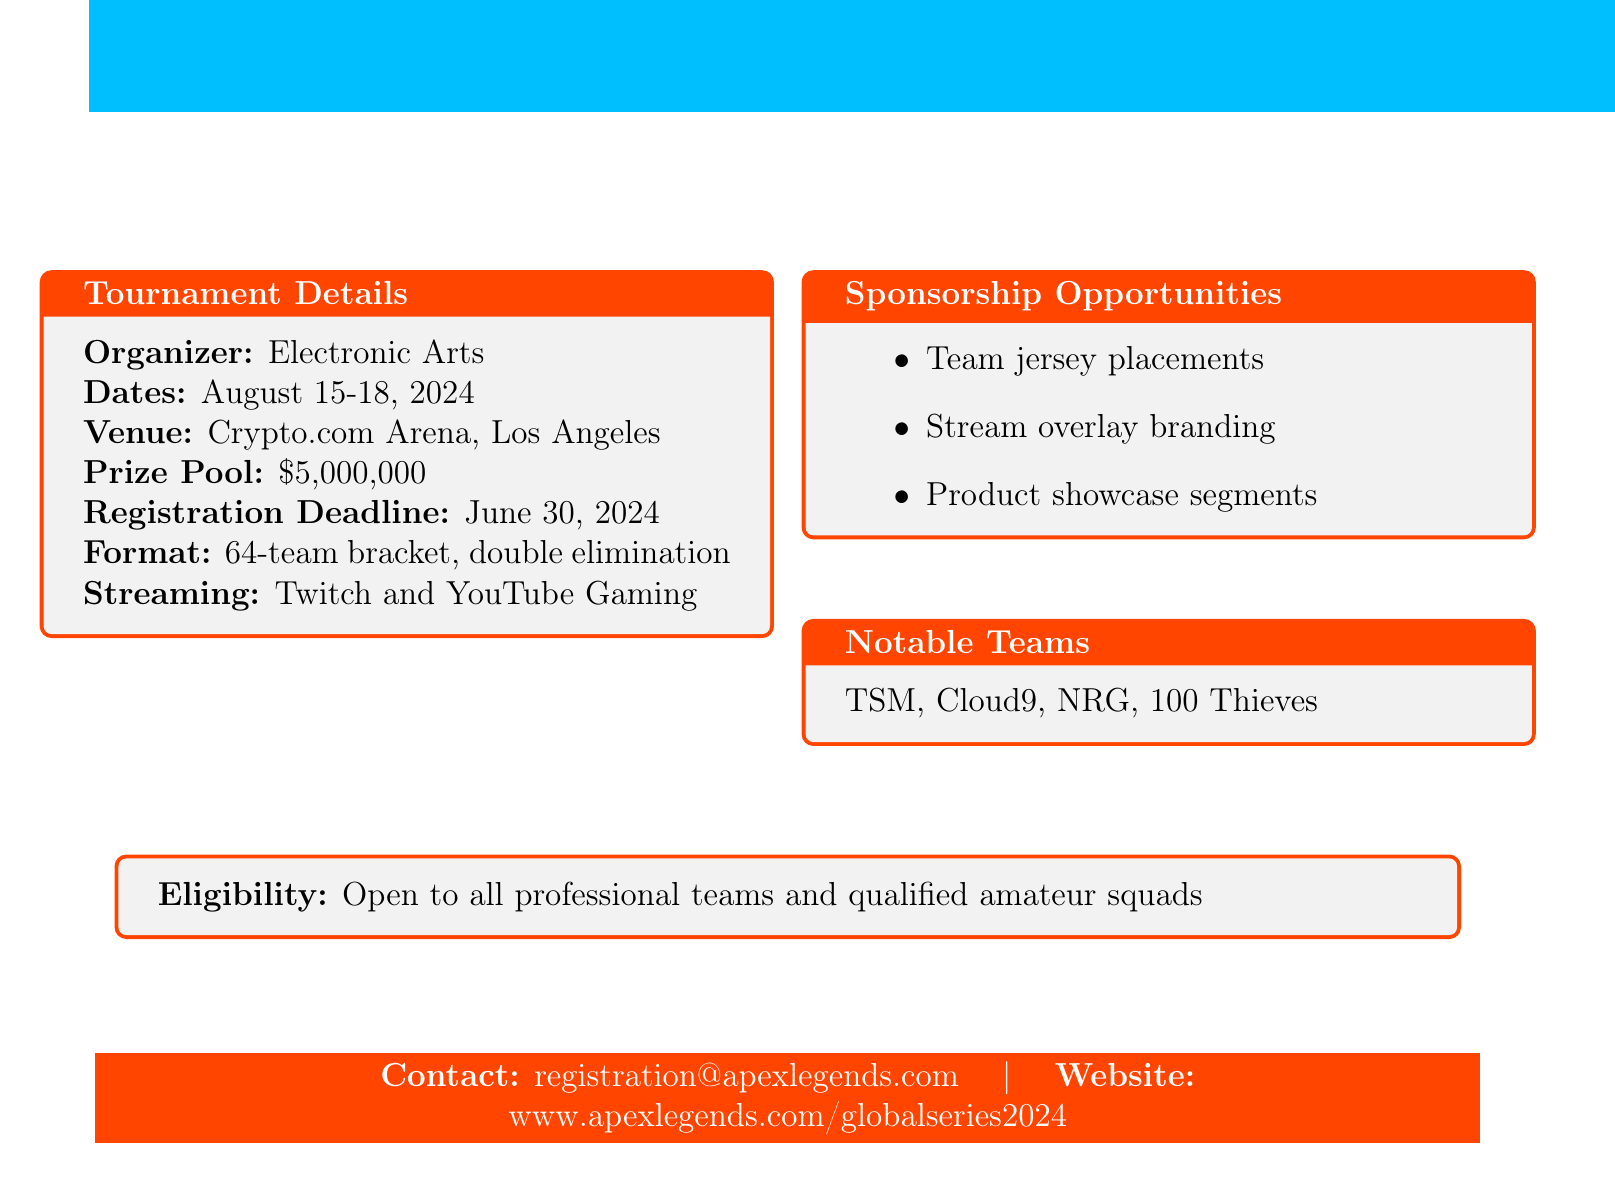What is the name of the tournament? The name of the tournament is specified in the header of the document.
Answer: Apex Legends Global Series 2024 Who is organizing the tournament? The organizer of the tournament is mentioned in the tournament details section.
Answer: Electronic Arts When is the registration deadline? The registration deadline is explicitly stated in the tournament details section.
Answer: June 30, 2024 What is the total prize pool? The total prize pool is listed in the tournament details section.
Answer: $5,000,000 How many teams are allowed in the tournament format? The number of teams is indicated in the format description in the document.
Answer: 64-team What are the notable teams mentioned? Notable teams are listed in the dedicated section for notable teams.
Answer: TSM, Cloud9, NRG, 100 Thieves What platforms will the tournament be streamed on? The streaming platforms are specified in the tournament details section.
Answer: Twitch and YouTube Gaming What kind of teams are eligible to participate? The eligibility requirements are provided in the document to clarify team types.
Answer: Open to all professional teams and qualified amateur squads What are some sponsorship opportunities available? The types of sponsorship opportunities are listed in the sponsorship section.
Answer: Team jersey placements, Stream overlay branding, Product showcase segments 